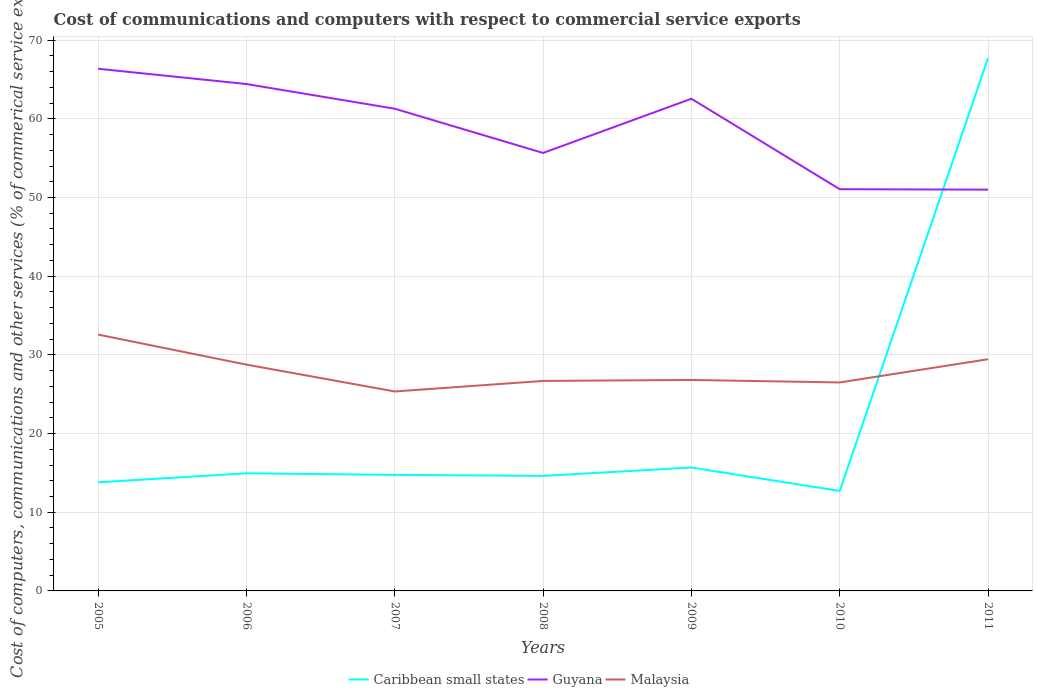Does the line corresponding to Malaysia intersect with the line corresponding to Caribbean small states?
Keep it short and to the point. Yes. Is the number of lines equal to the number of legend labels?
Keep it short and to the point. Yes. Across all years, what is the maximum cost of communications and computers in Caribbean small states?
Offer a terse response. 12.7. In which year was the cost of communications and computers in Guyana maximum?
Provide a short and direct response. 2011. What is the total cost of communications and computers in Guyana in the graph?
Keep it short and to the point. 5.08. What is the difference between the highest and the second highest cost of communications and computers in Guyana?
Make the answer very short. 15.36. What is the difference between the highest and the lowest cost of communications and computers in Guyana?
Ensure brevity in your answer.  4. What is the difference between two consecutive major ticks on the Y-axis?
Your response must be concise. 10. Are the values on the major ticks of Y-axis written in scientific E-notation?
Provide a succinct answer. No. Does the graph contain any zero values?
Your answer should be very brief. No. Does the graph contain grids?
Make the answer very short. Yes. What is the title of the graph?
Offer a terse response. Cost of communications and computers with respect to commercial service exports. What is the label or title of the X-axis?
Provide a short and direct response. Years. What is the label or title of the Y-axis?
Make the answer very short. Cost of computers, communications and other services (% of commerical service exports). What is the Cost of computers, communications and other services (% of commerical service exports) in Caribbean small states in 2005?
Provide a succinct answer. 13.81. What is the Cost of computers, communications and other services (% of commerical service exports) of Guyana in 2005?
Ensure brevity in your answer.  66.36. What is the Cost of computers, communications and other services (% of commerical service exports) of Malaysia in 2005?
Provide a short and direct response. 32.58. What is the Cost of computers, communications and other services (% of commerical service exports) in Caribbean small states in 2006?
Provide a succinct answer. 14.95. What is the Cost of computers, communications and other services (% of commerical service exports) of Guyana in 2006?
Keep it short and to the point. 64.42. What is the Cost of computers, communications and other services (% of commerical service exports) in Malaysia in 2006?
Your answer should be compact. 28.76. What is the Cost of computers, communications and other services (% of commerical service exports) of Caribbean small states in 2007?
Your answer should be compact. 14.75. What is the Cost of computers, communications and other services (% of commerical service exports) in Guyana in 2007?
Make the answer very short. 61.28. What is the Cost of computers, communications and other services (% of commerical service exports) of Malaysia in 2007?
Your answer should be compact. 25.35. What is the Cost of computers, communications and other services (% of commerical service exports) in Caribbean small states in 2008?
Provide a succinct answer. 14.62. What is the Cost of computers, communications and other services (% of commerical service exports) of Guyana in 2008?
Keep it short and to the point. 55.66. What is the Cost of computers, communications and other services (% of commerical service exports) of Malaysia in 2008?
Provide a short and direct response. 26.69. What is the Cost of computers, communications and other services (% of commerical service exports) in Caribbean small states in 2009?
Give a very brief answer. 15.68. What is the Cost of computers, communications and other services (% of commerical service exports) in Guyana in 2009?
Make the answer very short. 62.55. What is the Cost of computers, communications and other services (% of commerical service exports) in Malaysia in 2009?
Make the answer very short. 26.81. What is the Cost of computers, communications and other services (% of commerical service exports) of Caribbean small states in 2010?
Keep it short and to the point. 12.7. What is the Cost of computers, communications and other services (% of commerical service exports) of Guyana in 2010?
Make the answer very short. 51.06. What is the Cost of computers, communications and other services (% of commerical service exports) in Malaysia in 2010?
Provide a short and direct response. 26.5. What is the Cost of computers, communications and other services (% of commerical service exports) in Caribbean small states in 2011?
Ensure brevity in your answer.  67.71. What is the Cost of computers, communications and other services (% of commerical service exports) of Guyana in 2011?
Your answer should be compact. 51. What is the Cost of computers, communications and other services (% of commerical service exports) in Malaysia in 2011?
Make the answer very short. 29.45. Across all years, what is the maximum Cost of computers, communications and other services (% of commerical service exports) in Caribbean small states?
Keep it short and to the point. 67.71. Across all years, what is the maximum Cost of computers, communications and other services (% of commerical service exports) in Guyana?
Keep it short and to the point. 66.36. Across all years, what is the maximum Cost of computers, communications and other services (% of commerical service exports) of Malaysia?
Give a very brief answer. 32.58. Across all years, what is the minimum Cost of computers, communications and other services (% of commerical service exports) of Caribbean small states?
Give a very brief answer. 12.7. Across all years, what is the minimum Cost of computers, communications and other services (% of commerical service exports) of Guyana?
Provide a short and direct response. 51. Across all years, what is the minimum Cost of computers, communications and other services (% of commerical service exports) in Malaysia?
Give a very brief answer. 25.35. What is the total Cost of computers, communications and other services (% of commerical service exports) in Caribbean small states in the graph?
Your response must be concise. 154.22. What is the total Cost of computers, communications and other services (% of commerical service exports) of Guyana in the graph?
Offer a very short reply. 412.34. What is the total Cost of computers, communications and other services (% of commerical service exports) in Malaysia in the graph?
Keep it short and to the point. 196.14. What is the difference between the Cost of computers, communications and other services (% of commerical service exports) in Caribbean small states in 2005 and that in 2006?
Give a very brief answer. -1.14. What is the difference between the Cost of computers, communications and other services (% of commerical service exports) of Guyana in 2005 and that in 2006?
Your answer should be compact. 1.94. What is the difference between the Cost of computers, communications and other services (% of commerical service exports) of Malaysia in 2005 and that in 2006?
Provide a short and direct response. 3.82. What is the difference between the Cost of computers, communications and other services (% of commerical service exports) in Caribbean small states in 2005 and that in 2007?
Your response must be concise. -0.94. What is the difference between the Cost of computers, communications and other services (% of commerical service exports) of Guyana in 2005 and that in 2007?
Offer a terse response. 5.08. What is the difference between the Cost of computers, communications and other services (% of commerical service exports) of Malaysia in 2005 and that in 2007?
Offer a very short reply. 7.23. What is the difference between the Cost of computers, communications and other services (% of commerical service exports) in Caribbean small states in 2005 and that in 2008?
Offer a very short reply. -0.81. What is the difference between the Cost of computers, communications and other services (% of commerical service exports) of Guyana in 2005 and that in 2008?
Make the answer very short. 10.7. What is the difference between the Cost of computers, communications and other services (% of commerical service exports) of Malaysia in 2005 and that in 2008?
Keep it short and to the point. 5.89. What is the difference between the Cost of computers, communications and other services (% of commerical service exports) of Caribbean small states in 2005 and that in 2009?
Your response must be concise. -1.88. What is the difference between the Cost of computers, communications and other services (% of commerical service exports) of Guyana in 2005 and that in 2009?
Your answer should be very brief. 3.81. What is the difference between the Cost of computers, communications and other services (% of commerical service exports) in Malaysia in 2005 and that in 2009?
Offer a terse response. 5.76. What is the difference between the Cost of computers, communications and other services (% of commerical service exports) of Caribbean small states in 2005 and that in 2010?
Your response must be concise. 1.1. What is the difference between the Cost of computers, communications and other services (% of commerical service exports) of Guyana in 2005 and that in 2010?
Provide a short and direct response. 15.31. What is the difference between the Cost of computers, communications and other services (% of commerical service exports) of Malaysia in 2005 and that in 2010?
Your answer should be very brief. 6.08. What is the difference between the Cost of computers, communications and other services (% of commerical service exports) in Caribbean small states in 2005 and that in 2011?
Offer a terse response. -53.9. What is the difference between the Cost of computers, communications and other services (% of commerical service exports) of Guyana in 2005 and that in 2011?
Provide a short and direct response. 15.36. What is the difference between the Cost of computers, communications and other services (% of commerical service exports) of Malaysia in 2005 and that in 2011?
Your response must be concise. 3.13. What is the difference between the Cost of computers, communications and other services (% of commerical service exports) in Caribbean small states in 2006 and that in 2007?
Your answer should be compact. 0.2. What is the difference between the Cost of computers, communications and other services (% of commerical service exports) of Guyana in 2006 and that in 2007?
Keep it short and to the point. 3.14. What is the difference between the Cost of computers, communications and other services (% of commerical service exports) in Malaysia in 2006 and that in 2007?
Make the answer very short. 3.41. What is the difference between the Cost of computers, communications and other services (% of commerical service exports) in Caribbean small states in 2006 and that in 2008?
Offer a very short reply. 0.33. What is the difference between the Cost of computers, communications and other services (% of commerical service exports) in Guyana in 2006 and that in 2008?
Give a very brief answer. 8.76. What is the difference between the Cost of computers, communications and other services (% of commerical service exports) of Malaysia in 2006 and that in 2008?
Offer a terse response. 2.07. What is the difference between the Cost of computers, communications and other services (% of commerical service exports) in Caribbean small states in 2006 and that in 2009?
Your response must be concise. -0.73. What is the difference between the Cost of computers, communications and other services (% of commerical service exports) of Guyana in 2006 and that in 2009?
Keep it short and to the point. 1.87. What is the difference between the Cost of computers, communications and other services (% of commerical service exports) of Malaysia in 2006 and that in 2009?
Your answer should be compact. 1.94. What is the difference between the Cost of computers, communications and other services (% of commerical service exports) of Caribbean small states in 2006 and that in 2010?
Ensure brevity in your answer.  2.25. What is the difference between the Cost of computers, communications and other services (% of commerical service exports) in Guyana in 2006 and that in 2010?
Offer a very short reply. 13.36. What is the difference between the Cost of computers, communications and other services (% of commerical service exports) in Malaysia in 2006 and that in 2010?
Provide a short and direct response. 2.26. What is the difference between the Cost of computers, communications and other services (% of commerical service exports) of Caribbean small states in 2006 and that in 2011?
Provide a succinct answer. -52.75. What is the difference between the Cost of computers, communications and other services (% of commerical service exports) of Guyana in 2006 and that in 2011?
Your response must be concise. 13.42. What is the difference between the Cost of computers, communications and other services (% of commerical service exports) of Malaysia in 2006 and that in 2011?
Provide a short and direct response. -0.69. What is the difference between the Cost of computers, communications and other services (% of commerical service exports) in Caribbean small states in 2007 and that in 2008?
Your response must be concise. 0.13. What is the difference between the Cost of computers, communications and other services (% of commerical service exports) of Guyana in 2007 and that in 2008?
Provide a short and direct response. 5.62. What is the difference between the Cost of computers, communications and other services (% of commerical service exports) of Malaysia in 2007 and that in 2008?
Offer a very short reply. -1.34. What is the difference between the Cost of computers, communications and other services (% of commerical service exports) in Caribbean small states in 2007 and that in 2009?
Offer a terse response. -0.94. What is the difference between the Cost of computers, communications and other services (% of commerical service exports) in Guyana in 2007 and that in 2009?
Provide a short and direct response. -1.27. What is the difference between the Cost of computers, communications and other services (% of commerical service exports) of Malaysia in 2007 and that in 2009?
Your answer should be compact. -1.46. What is the difference between the Cost of computers, communications and other services (% of commerical service exports) of Caribbean small states in 2007 and that in 2010?
Keep it short and to the point. 2.04. What is the difference between the Cost of computers, communications and other services (% of commerical service exports) of Guyana in 2007 and that in 2010?
Offer a very short reply. 10.23. What is the difference between the Cost of computers, communications and other services (% of commerical service exports) in Malaysia in 2007 and that in 2010?
Provide a short and direct response. -1.15. What is the difference between the Cost of computers, communications and other services (% of commerical service exports) of Caribbean small states in 2007 and that in 2011?
Offer a terse response. -52.96. What is the difference between the Cost of computers, communications and other services (% of commerical service exports) of Guyana in 2007 and that in 2011?
Ensure brevity in your answer.  10.28. What is the difference between the Cost of computers, communications and other services (% of commerical service exports) of Malaysia in 2007 and that in 2011?
Ensure brevity in your answer.  -4.1. What is the difference between the Cost of computers, communications and other services (% of commerical service exports) of Caribbean small states in 2008 and that in 2009?
Your answer should be compact. -1.06. What is the difference between the Cost of computers, communications and other services (% of commerical service exports) of Guyana in 2008 and that in 2009?
Keep it short and to the point. -6.89. What is the difference between the Cost of computers, communications and other services (% of commerical service exports) in Malaysia in 2008 and that in 2009?
Your answer should be very brief. -0.12. What is the difference between the Cost of computers, communications and other services (% of commerical service exports) of Caribbean small states in 2008 and that in 2010?
Offer a terse response. 1.91. What is the difference between the Cost of computers, communications and other services (% of commerical service exports) of Guyana in 2008 and that in 2010?
Offer a terse response. 4.6. What is the difference between the Cost of computers, communications and other services (% of commerical service exports) of Malaysia in 2008 and that in 2010?
Your response must be concise. 0.19. What is the difference between the Cost of computers, communications and other services (% of commerical service exports) of Caribbean small states in 2008 and that in 2011?
Make the answer very short. -53.09. What is the difference between the Cost of computers, communications and other services (% of commerical service exports) in Guyana in 2008 and that in 2011?
Keep it short and to the point. 4.66. What is the difference between the Cost of computers, communications and other services (% of commerical service exports) of Malaysia in 2008 and that in 2011?
Offer a very short reply. -2.76. What is the difference between the Cost of computers, communications and other services (% of commerical service exports) in Caribbean small states in 2009 and that in 2010?
Your response must be concise. 2.98. What is the difference between the Cost of computers, communications and other services (% of commerical service exports) of Guyana in 2009 and that in 2010?
Provide a succinct answer. 11.5. What is the difference between the Cost of computers, communications and other services (% of commerical service exports) of Malaysia in 2009 and that in 2010?
Keep it short and to the point. 0.32. What is the difference between the Cost of computers, communications and other services (% of commerical service exports) in Caribbean small states in 2009 and that in 2011?
Your response must be concise. -52.02. What is the difference between the Cost of computers, communications and other services (% of commerical service exports) of Guyana in 2009 and that in 2011?
Ensure brevity in your answer.  11.55. What is the difference between the Cost of computers, communications and other services (% of commerical service exports) in Malaysia in 2009 and that in 2011?
Provide a succinct answer. -2.63. What is the difference between the Cost of computers, communications and other services (% of commerical service exports) of Caribbean small states in 2010 and that in 2011?
Keep it short and to the point. -55. What is the difference between the Cost of computers, communications and other services (% of commerical service exports) of Guyana in 2010 and that in 2011?
Provide a succinct answer. 0.06. What is the difference between the Cost of computers, communications and other services (% of commerical service exports) in Malaysia in 2010 and that in 2011?
Provide a short and direct response. -2.95. What is the difference between the Cost of computers, communications and other services (% of commerical service exports) of Caribbean small states in 2005 and the Cost of computers, communications and other services (% of commerical service exports) of Guyana in 2006?
Give a very brief answer. -50.62. What is the difference between the Cost of computers, communications and other services (% of commerical service exports) in Caribbean small states in 2005 and the Cost of computers, communications and other services (% of commerical service exports) in Malaysia in 2006?
Give a very brief answer. -14.95. What is the difference between the Cost of computers, communications and other services (% of commerical service exports) of Guyana in 2005 and the Cost of computers, communications and other services (% of commerical service exports) of Malaysia in 2006?
Make the answer very short. 37.61. What is the difference between the Cost of computers, communications and other services (% of commerical service exports) of Caribbean small states in 2005 and the Cost of computers, communications and other services (% of commerical service exports) of Guyana in 2007?
Offer a very short reply. -47.48. What is the difference between the Cost of computers, communications and other services (% of commerical service exports) of Caribbean small states in 2005 and the Cost of computers, communications and other services (% of commerical service exports) of Malaysia in 2007?
Offer a very short reply. -11.54. What is the difference between the Cost of computers, communications and other services (% of commerical service exports) in Guyana in 2005 and the Cost of computers, communications and other services (% of commerical service exports) in Malaysia in 2007?
Make the answer very short. 41.01. What is the difference between the Cost of computers, communications and other services (% of commerical service exports) of Caribbean small states in 2005 and the Cost of computers, communications and other services (% of commerical service exports) of Guyana in 2008?
Give a very brief answer. -41.86. What is the difference between the Cost of computers, communications and other services (% of commerical service exports) of Caribbean small states in 2005 and the Cost of computers, communications and other services (% of commerical service exports) of Malaysia in 2008?
Provide a succinct answer. -12.88. What is the difference between the Cost of computers, communications and other services (% of commerical service exports) of Guyana in 2005 and the Cost of computers, communications and other services (% of commerical service exports) of Malaysia in 2008?
Offer a very short reply. 39.68. What is the difference between the Cost of computers, communications and other services (% of commerical service exports) of Caribbean small states in 2005 and the Cost of computers, communications and other services (% of commerical service exports) of Guyana in 2009?
Your response must be concise. -48.75. What is the difference between the Cost of computers, communications and other services (% of commerical service exports) in Caribbean small states in 2005 and the Cost of computers, communications and other services (% of commerical service exports) in Malaysia in 2009?
Provide a short and direct response. -13.01. What is the difference between the Cost of computers, communications and other services (% of commerical service exports) of Guyana in 2005 and the Cost of computers, communications and other services (% of commerical service exports) of Malaysia in 2009?
Your answer should be compact. 39.55. What is the difference between the Cost of computers, communications and other services (% of commerical service exports) in Caribbean small states in 2005 and the Cost of computers, communications and other services (% of commerical service exports) in Guyana in 2010?
Give a very brief answer. -37.25. What is the difference between the Cost of computers, communications and other services (% of commerical service exports) of Caribbean small states in 2005 and the Cost of computers, communications and other services (% of commerical service exports) of Malaysia in 2010?
Offer a very short reply. -12.69. What is the difference between the Cost of computers, communications and other services (% of commerical service exports) of Guyana in 2005 and the Cost of computers, communications and other services (% of commerical service exports) of Malaysia in 2010?
Ensure brevity in your answer.  39.87. What is the difference between the Cost of computers, communications and other services (% of commerical service exports) of Caribbean small states in 2005 and the Cost of computers, communications and other services (% of commerical service exports) of Guyana in 2011?
Provide a succinct answer. -37.19. What is the difference between the Cost of computers, communications and other services (% of commerical service exports) in Caribbean small states in 2005 and the Cost of computers, communications and other services (% of commerical service exports) in Malaysia in 2011?
Keep it short and to the point. -15.64. What is the difference between the Cost of computers, communications and other services (% of commerical service exports) in Guyana in 2005 and the Cost of computers, communications and other services (% of commerical service exports) in Malaysia in 2011?
Keep it short and to the point. 36.92. What is the difference between the Cost of computers, communications and other services (% of commerical service exports) in Caribbean small states in 2006 and the Cost of computers, communications and other services (% of commerical service exports) in Guyana in 2007?
Your answer should be compact. -46.33. What is the difference between the Cost of computers, communications and other services (% of commerical service exports) of Caribbean small states in 2006 and the Cost of computers, communications and other services (% of commerical service exports) of Malaysia in 2007?
Provide a succinct answer. -10.4. What is the difference between the Cost of computers, communications and other services (% of commerical service exports) in Guyana in 2006 and the Cost of computers, communications and other services (% of commerical service exports) in Malaysia in 2007?
Your answer should be very brief. 39.07. What is the difference between the Cost of computers, communications and other services (% of commerical service exports) of Caribbean small states in 2006 and the Cost of computers, communications and other services (% of commerical service exports) of Guyana in 2008?
Keep it short and to the point. -40.71. What is the difference between the Cost of computers, communications and other services (% of commerical service exports) of Caribbean small states in 2006 and the Cost of computers, communications and other services (% of commerical service exports) of Malaysia in 2008?
Ensure brevity in your answer.  -11.74. What is the difference between the Cost of computers, communications and other services (% of commerical service exports) of Guyana in 2006 and the Cost of computers, communications and other services (% of commerical service exports) of Malaysia in 2008?
Ensure brevity in your answer.  37.73. What is the difference between the Cost of computers, communications and other services (% of commerical service exports) in Caribbean small states in 2006 and the Cost of computers, communications and other services (% of commerical service exports) in Guyana in 2009?
Provide a short and direct response. -47.6. What is the difference between the Cost of computers, communications and other services (% of commerical service exports) of Caribbean small states in 2006 and the Cost of computers, communications and other services (% of commerical service exports) of Malaysia in 2009?
Give a very brief answer. -11.86. What is the difference between the Cost of computers, communications and other services (% of commerical service exports) of Guyana in 2006 and the Cost of computers, communications and other services (% of commerical service exports) of Malaysia in 2009?
Your response must be concise. 37.61. What is the difference between the Cost of computers, communications and other services (% of commerical service exports) of Caribbean small states in 2006 and the Cost of computers, communications and other services (% of commerical service exports) of Guyana in 2010?
Keep it short and to the point. -36.11. What is the difference between the Cost of computers, communications and other services (% of commerical service exports) in Caribbean small states in 2006 and the Cost of computers, communications and other services (% of commerical service exports) in Malaysia in 2010?
Offer a very short reply. -11.55. What is the difference between the Cost of computers, communications and other services (% of commerical service exports) in Guyana in 2006 and the Cost of computers, communications and other services (% of commerical service exports) in Malaysia in 2010?
Your answer should be compact. 37.92. What is the difference between the Cost of computers, communications and other services (% of commerical service exports) of Caribbean small states in 2006 and the Cost of computers, communications and other services (% of commerical service exports) of Guyana in 2011?
Your answer should be compact. -36.05. What is the difference between the Cost of computers, communications and other services (% of commerical service exports) of Caribbean small states in 2006 and the Cost of computers, communications and other services (% of commerical service exports) of Malaysia in 2011?
Your answer should be compact. -14.5. What is the difference between the Cost of computers, communications and other services (% of commerical service exports) in Guyana in 2006 and the Cost of computers, communications and other services (% of commerical service exports) in Malaysia in 2011?
Keep it short and to the point. 34.97. What is the difference between the Cost of computers, communications and other services (% of commerical service exports) of Caribbean small states in 2007 and the Cost of computers, communications and other services (% of commerical service exports) of Guyana in 2008?
Offer a terse response. -40.91. What is the difference between the Cost of computers, communications and other services (% of commerical service exports) of Caribbean small states in 2007 and the Cost of computers, communications and other services (% of commerical service exports) of Malaysia in 2008?
Ensure brevity in your answer.  -11.94. What is the difference between the Cost of computers, communications and other services (% of commerical service exports) of Guyana in 2007 and the Cost of computers, communications and other services (% of commerical service exports) of Malaysia in 2008?
Your answer should be very brief. 34.59. What is the difference between the Cost of computers, communications and other services (% of commerical service exports) in Caribbean small states in 2007 and the Cost of computers, communications and other services (% of commerical service exports) in Guyana in 2009?
Provide a succinct answer. -47.81. What is the difference between the Cost of computers, communications and other services (% of commerical service exports) of Caribbean small states in 2007 and the Cost of computers, communications and other services (% of commerical service exports) of Malaysia in 2009?
Provide a short and direct response. -12.07. What is the difference between the Cost of computers, communications and other services (% of commerical service exports) in Guyana in 2007 and the Cost of computers, communications and other services (% of commerical service exports) in Malaysia in 2009?
Offer a terse response. 34.47. What is the difference between the Cost of computers, communications and other services (% of commerical service exports) in Caribbean small states in 2007 and the Cost of computers, communications and other services (% of commerical service exports) in Guyana in 2010?
Offer a very short reply. -36.31. What is the difference between the Cost of computers, communications and other services (% of commerical service exports) in Caribbean small states in 2007 and the Cost of computers, communications and other services (% of commerical service exports) in Malaysia in 2010?
Give a very brief answer. -11.75. What is the difference between the Cost of computers, communications and other services (% of commerical service exports) of Guyana in 2007 and the Cost of computers, communications and other services (% of commerical service exports) of Malaysia in 2010?
Give a very brief answer. 34.79. What is the difference between the Cost of computers, communications and other services (% of commerical service exports) of Caribbean small states in 2007 and the Cost of computers, communications and other services (% of commerical service exports) of Guyana in 2011?
Offer a very short reply. -36.25. What is the difference between the Cost of computers, communications and other services (% of commerical service exports) in Caribbean small states in 2007 and the Cost of computers, communications and other services (% of commerical service exports) in Malaysia in 2011?
Your answer should be very brief. -14.7. What is the difference between the Cost of computers, communications and other services (% of commerical service exports) of Guyana in 2007 and the Cost of computers, communications and other services (% of commerical service exports) of Malaysia in 2011?
Give a very brief answer. 31.84. What is the difference between the Cost of computers, communications and other services (% of commerical service exports) in Caribbean small states in 2008 and the Cost of computers, communications and other services (% of commerical service exports) in Guyana in 2009?
Give a very brief answer. -47.94. What is the difference between the Cost of computers, communications and other services (% of commerical service exports) in Caribbean small states in 2008 and the Cost of computers, communications and other services (% of commerical service exports) in Malaysia in 2009?
Your response must be concise. -12.19. What is the difference between the Cost of computers, communications and other services (% of commerical service exports) of Guyana in 2008 and the Cost of computers, communications and other services (% of commerical service exports) of Malaysia in 2009?
Offer a very short reply. 28.85. What is the difference between the Cost of computers, communications and other services (% of commerical service exports) in Caribbean small states in 2008 and the Cost of computers, communications and other services (% of commerical service exports) in Guyana in 2010?
Provide a succinct answer. -36.44. What is the difference between the Cost of computers, communications and other services (% of commerical service exports) in Caribbean small states in 2008 and the Cost of computers, communications and other services (% of commerical service exports) in Malaysia in 2010?
Make the answer very short. -11.88. What is the difference between the Cost of computers, communications and other services (% of commerical service exports) of Guyana in 2008 and the Cost of computers, communications and other services (% of commerical service exports) of Malaysia in 2010?
Your answer should be compact. 29.16. What is the difference between the Cost of computers, communications and other services (% of commerical service exports) of Caribbean small states in 2008 and the Cost of computers, communications and other services (% of commerical service exports) of Guyana in 2011?
Offer a terse response. -36.38. What is the difference between the Cost of computers, communications and other services (% of commerical service exports) of Caribbean small states in 2008 and the Cost of computers, communications and other services (% of commerical service exports) of Malaysia in 2011?
Make the answer very short. -14.83. What is the difference between the Cost of computers, communications and other services (% of commerical service exports) in Guyana in 2008 and the Cost of computers, communications and other services (% of commerical service exports) in Malaysia in 2011?
Your answer should be compact. 26.21. What is the difference between the Cost of computers, communications and other services (% of commerical service exports) of Caribbean small states in 2009 and the Cost of computers, communications and other services (% of commerical service exports) of Guyana in 2010?
Make the answer very short. -35.37. What is the difference between the Cost of computers, communications and other services (% of commerical service exports) in Caribbean small states in 2009 and the Cost of computers, communications and other services (% of commerical service exports) in Malaysia in 2010?
Offer a very short reply. -10.81. What is the difference between the Cost of computers, communications and other services (% of commerical service exports) in Guyana in 2009 and the Cost of computers, communications and other services (% of commerical service exports) in Malaysia in 2010?
Offer a terse response. 36.06. What is the difference between the Cost of computers, communications and other services (% of commerical service exports) of Caribbean small states in 2009 and the Cost of computers, communications and other services (% of commerical service exports) of Guyana in 2011?
Your answer should be very brief. -35.32. What is the difference between the Cost of computers, communications and other services (% of commerical service exports) of Caribbean small states in 2009 and the Cost of computers, communications and other services (% of commerical service exports) of Malaysia in 2011?
Make the answer very short. -13.76. What is the difference between the Cost of computers, communications and other services (% of commerical service exports) of Guyana in 2009 and the Cost of computers, communications and other services (% of commerical service exports) of Malaysia in 2011?
Keep it short and to the point. 33.11. What is the difference between the Cost of computers, communications and other services (% of commerical service exports) of Caribbean small states in 2010 and the Cost of computers, communications and other services (% of commerical service exports) of Guyana in 2011?
Offer a very short reply. -38.3. What is the difference between the Cost of computers, communications and other services (% of commerical service exports) in Caribbean small states in 2010 and the Cost of computers, communications and other services (% of commerical service exports) in Malaysia in 2011?
Your answer should be compact. -16.74. What is the difference between the Cost of computers, communications and other services (% of commerical service exports) in Guyana in 2010 and the Cost of computers, communications and other services (% of commerical service exports) in Malaysia in 2011?
Provide a short and direct response. 21.61. What is the average Cost of computers, communications and other services (% of commerical service exports) in Caribbean small states per year?
Keep it short and to the point. 22.03. What is the average Cost of computers, communications and other services (% of commerical service exports) in Guyana per year?
Your answer should be very brief. 58.91. What is the average Cost of computers, communications and other services (% of commerical service exports) in Malaysia per year?
Ensure brevity in your answer.  28.02. In the year 2005, what is the difference between the Cost of computers, communications and other services (% of commerical service exports) of Caribbean small states and Cost of computers, communications and other services (% of commerical service exports) of Guyana?
Your answer should be compact. -52.56. In the year 2005, what is the difference between the Cost of computers, communications and other services (% of commerical service exports) of Caribbean small states and Cost of computers, communications and other services (% of commerical service exports) of Malaysia?
Keep it short and to the point. -18.77. In the year 2005, what is the difference between the Cost of computers, communications and other services (% of commerical service exports) of Guyana and Cost of computers, communications and other services (% of commerical service exports) of Malaysia?
Ensure brevity in your answer.  33.79. In the year 2006, what is the difference between the Cost of computers, communications and other services (% of commerical service exports) of Caribbean small states and Cost of computers, communications and other services (% of commerical service exports) of Guyana?
Make the answer very short. -49.47. In the year 2006, what is the difference between the Cost of computers, communications and other services (% of commerical service exports) in Caribbean small states and Cost of computers, communications and other services (% of commerical service exports) in Malaysia?
Ensure brevity in your answer.  -13.81. In the year 2006, what is the difference between the Cost of computers, communications and other services (% of commerical service exports) in Guyana and Cost of computers, communications and other services (% of commerical service exports) in Malaysia?
Offer a very short reply. 35.66. In the year 2007, what is the difference between the Cost of computers, communications and other services (% of commerical service exports) of Caribbean small states and Cost of computers, communications and other services (% of commerical service exports) of Guyana?
Your response must be concise. -46.54. In the year 2007, what is the difference between the Cost of computers, communications and other services (% of commerical service exports) of Caribbean small states and Cost of computers, communications and other services (% of commerical service exports) of Malaysia?
Make the answer very short. -10.6. In the year 2007, what is the difference between the Cost of computers, communications and other services (% of commerical service exports) in Guyana and Cost of computers, communications and other services (% of commerical service exports) in Malaysia?
Offer a terse response. 35.93. In the year 2008, what is the difference between the Cost of computers, communications and other services (% of commerical service exports) of Caribbean small states and Cost of computers, communications and other services (% of commerical service exports) of Guyana?
Keep it short and to the point. -41.04. In the year 2008, what is the difference between the Cost of computers, communications and other services (% of commerical service exports) in Caribbean small states and Cost of computers, communications and other services (% of commerical service exports) in Malaysia?
Your answer should be very brief. -12.07. In the year 2008, what is the difference between the Cost of computers, communications and other services (% of commerical service exports) in Guyana and Cost of computers, communications and other services (% of commerical service exports) in Malaysia?
Give a very brief answer. 28.97. In the year 2009, what is the difference between the Cost of computers, communications and other services (% of commerical service exports) in Caribbean small states and Cost of computers, communications and other services (% of commerical service exports) in Guyana?
Make the answer very short. -46.87. In the year 2009, what is the difference between the Cost of computers, communications and other services (% of commerical service exports) of Caribbean small states and Cost of computers, communications and other services (% of commerical service exports) of Malaysia?
Ensure brevity in your answer.  -11.13. In the year 2009, what is the difference between the Cost of computers, communications and other services (% of commerical service exports) in Guyana and Cost of computers, communications and other services (% of commerical service exports) in Malaysia?
Offer a terse response. 35.74. In the year 2010, what is the difference between the Cost of computers, communications and other services (% of commerical service exports) in Caribbean small states and Cost of computers, communications and other services (% of commerical service exports) in Guyana?
Your response must be concise. -38.35. In the year 2010, what is the difference between the Cost of computers, communications and other services (% of commerical service exports) in Caribbean small states and Cost of computers, communications and other services (% of commerical service exports) in Malaysia?
Provide a short and direct response. -13.79. In the year 2010, what is the difference between the Cost of computers, communications and other services (% of commerical service exports) in Guyana and Cost of computers, communications and other services (% of commerical service exports) in Malaysia?
Offer a very short reply. 24.56. In the year 2011, what is the difference between the Cost of computers, communications and other services (% of commerical service exports) of Caribbean small states and Cost of computers, communications and other services (% of commerical service exports) of Guyana?
Offer a terse response. 16.7. In the year 2011, what is the difference between the Cost of computers, communications and other services (% of commerical service exports) of Caribbean small states and Cost of computers, communications and other services (% of commerical service exports) of Malaysia?
Offer a terse response. 38.26. In the year 2011, what is the difference between the Cost of computers, communications and other services (% of commerical service exports) in Guyana and Cost of computers, communications and other services (% of commerical service exports) in Malaysia?
Make the answer very short. 21.55. What is the ratio of the Cost of computers, communications and other services (% of commerical service exports) of Caribbean small states in 2005 to that in 2006?
Provide a succinct answer. 0.92. What is the ratio of the Cost of computers, communications and other services (% of commerical service exports) of Guyana in 2005 to that in 2006?
Provide a succinct answer. 1.03. What is the ratio of the Cost of computers, communications and other services (% of commerical service exports) of Malaysia in 2005 to that in 2006?
Keep it short and to the point. 1.13. What is the ratio of the Cost of computers, communications and other services (% of commerical service exports) in Caribbean small states in 2005 to that in 2007?
Your answer should be very brief. 0.94. What is the ratio of the Cost of computers, communications and other services (% of commerical service exports) in Guyana in 2005 to that in 2007?
Make the answer very short. 1.08. What is the ratio of the Cost of computers, communications and other services (% of commerical service exports) of Malaysia in 2005 to that in 2007?
Your response must be concise. 1.29. What is the ratio of the Cost of computers, communications and other services (% of commerical service exports) of Caribbean small states in 2005 to that in 2008?
Your answer should be very brief. 0.94. What is the ratio of the Cost of computers, communications and other services (% of commerical service exports) of Guyana in 2005 to that in 2008?
Give a very brief answer. 1.19. What is the ratio of the Cost of computers, communications and other services (% of commerical service exports) of Malaysia in 2005 to that in 2008?
Your response must be concise. 1.22. What is the ratio of the Cost of computers, communications and other services (% of commerical service exports) in Caribbean small states in 2005 to that in 2009?
Your answer should be compact. 0.88. What is the ratio of the Cost of computers, communications and other services (% of commerical service exports) in Guyana in 2005 to that in 2009?
Provide a succinct answer. 1.06. What is the ratio of the Cost of computers, communications and other services (% of commerical service exports) of Malaysia in 2005 to that in 2009?
Keep it short and to the point. 1.21. What is the ratio of the Cost of computers, communications and other services (% of commerical service exports) in Caribbean small states in 2005 to that in 2010?
Provide a succinct answer. 1.09. What is the ratio of the Cost of computers, communications and other services (% of commerical service exports) of Guyana in 2005 to that in 2010?
Provide a short and direct response. 1.3. What is the ratio of the Cost of computers, communications and other services (% of commerical service exports) of Malaysia in 2005 to that in 2010?
Your response must be concise. 1.23. What is the ratio of the Cost of computers, communications and other services (% of commerical service exports) of Caribbean small states in 2005 to that in 2011?
Your answer should be very brief. 0.2. What is the ratio of the Cost of computers, communications and other services (% of commerical service exports) of Guyana in 2005 to that in 2011?
Provide a short and direct response. 1.3. What is the ratio of the Cost of computers, communications and other services (% of commerical service exports) in Malaysia in 2005 to that in 2011?
Offer a very short reply. 1.11. What is the ratio of the Cost of computers, communications and other services (% of commerical service exports) of Caribbean small states in 2006 to that in 2007?
Provide a short and direct response. 1.01. What is the ratio of the Cost of computers, communications and other services (% of commerical service exports) of Guyana in 2006 to that in 2007?
Make the answer very short. 1.05. What is the ratio of the Cost of computers, communications and other services (% of commerical service exports) in Malaysia in 2006 to that in 2007?
Your response must be concise. 1.13. What is the ratio of the Cost of computers, communications and other services (% of commerical service exports) in Caribbean small states in 2006 to that in 2008?
Provide a short and direct response. 1.02. What is the ratio of the Cost of computers, communications and other services (% of commerical service exports) of Guyana in 2006 to that in 2008?
Offer a very short reply. 1.16. What is the ratio of the Cost of computers, communications and other services (% of commerical service exports) of Malaysia in 2006 to that in 2008?
Your answer should be compact. 1.08. What is the ratio of the Cost of computers, communications and other services (% of commerical service exports) in Caribbean small states in 2006 to that in 2009?
Keep it short and to the point. 0.95. What is the ratio of the Cost of computers, communications and other services (% of commerical service exports) of Guyana in 2006 to that in 2009?
Your response must be concise. 1.03. What is the ratio of the Cost of computers, communications and other services (% of commerical service exports) of Malaysia in 2006 to that in 2009?
Provide a succinct answer. 1.07. What is the ratio of the Cost of computers, communications and other services (% of commerical service exports) of Caribbean small states in 2006 to that in 2010?
Keep it short and to the point. 1.18. What is the ratio of the Cost of computers, communications and other services (% of commerical service exports) in Guyana in 2006 to that in 2010?
Give a very brief answer. 1.26. What is the ratio of the Cost of computers, communications and other services (% of commerical service exports) of Malaysia in 2006 to that in 2010?
Ensure brevity in your answer.  1.09. What is the ratio of the Cost of computers, communications and other services (% of commerical service exports) in Caribbean small states in 2006 to that in 2011?
Offer a very short reply. 0.22. What is the ratio of the Cost of computers, communications and other services (% of commerical service exports) of Guyana in 2006 to that in 2011?
Make the answer very short. 1.26. What is the ratio of the Cost of computers, communications and other services (% of commerical service exports) of Malaysia in 2006 to that in 2011?
Provide a succinct answer. 0.98. What is the ratio of the Cost of computers, communications and other services (% of commerical service exports) of Caribbean small states in 2007 to that in 2008?
Offer a very short reply. 1.01. What is the ratio of the Cost of computers, communications and other services (% of commerical service exports) of Guyana in 2007 to that in 2008?
Your response must be concise. 1.1. What is the ratio of the Cost of computers, communications and other services (% of commerical service exports) of Malaysia in 2007 to that in 2008?
Give a very brief answer. 0.95. What is the ratio of the Cost of computers, communications and other services (% of commerical service exports) in Caribbean small states in 2007 to that in 2009?
Ensure brevity in your answer.  0.94. What is the ratio of the Cost of computers, communications and other services (% of commerical service exports) of Guyana in 2007 to that in 2009?
Offer a terse response. 0.98. What is the ratio of the Cost of computers, communications and other services (% of commerical service exports) of Malaysia in 2007 to that in 2009?
Your answer should be compact. 0.95. What is the ratio of the Cost of computers, communications and other services (% of commerical service exports) in Caribbean small states in 2007 to that in 2010?
Offer a very short reply. 1.16. What is the ratio of the Cost of computers, communications and other services (% of commerical service exports) in Guyana in 2007 to that in 2010?
Provide a succinct answer. 1.2. What is the ratio of the Cost of computers, communications and other services (% of commerical service exports) of Malaysia in 2007 to that in 2010?
Make the answer very short. 0.96. What is the ratio of the Cost of computers, communications and other services (% of commerical service exports) in Caribbean small states in 2007 to that in 2011?
Provide a succinct answer. 0.22. What is the ratio of the Cost of computers, communications and other services (% of commerical service exports) in Guyana in 2007 to that in 2011?
Provide a short and direct response. 1.2. What is the ratio of the Cost of computers, communications and other services (% of commerical service exports) in Malaysia in 2007 to that in 2011?
Provide a short and direct response. 0.86. What is the ratio of the Cost of computers, communications and other services (% of commerical service exports) in Caribbean small states in 2008 to that in 2009?
Give a very brief answer. 0.93. What is the ratio of the Cost of computers, communications and other services (% of commerical service exports) in Guyana in 2008 to that in 2009?
Your response must be concise. 0.89. What is the ratio of the Cost of computers, communications and other services (% of commerical service exports) of Caribbean small states in 2008 to that in 2010?
Your answer should be compact. 1.15. What is the ratio of the Cost of computers, communications and other services (% of commerical service exports) in Guyana in 2008 to that in 2010?
Ensure brevity in your answer.  1.09. What is the ratio of the Cost of computers, communications and other services (% of commerical service exports) of Malaysia in 2008 to that in 2010?
Keep it short and to the point. 1.01. What is the ratio of the Cost of computers, communications and other services (% of commerical service exports) in Caribbean small states in 2008 to that in 2011?
Give a very brief answer. 0.22. What is the ratio of the Cost of computers, communications and other services (% of commerical service exports) of Guyana in 2008 to that in 2011?
Your answer should be very brief. 1.09. What is the ratio of the Cost of computers, communications and other services (% of commerical service exports) in Malaysia in 2008 to that in 2011?
Give a very brief answer. 0.91. What is the ratio of the Cost of computers, communications and other services (% of commerical service exports) of Caribbean small states in 2009 to that in 2010?
Make the answer very short. 1.23. What is the ratio of the Cost of computers, communications and other services (% of commerical service exports) of Guyana in 2009 to that in 2010?
Offer a very short reply. 1.23. What is the ratio of the Cost of computers, communications and other services (% of commerical service exports) of Malaysia in 2009 to that in 2010?
Your answer should be compact. 1.01. What is the ratio of the Cost of computers, communications and other services (% of commerical service exports) in Caribbean small states in 2009 to that in 2011?
Offer a terse response. 0.23. What is the ratio of the Cost of computers, communications and other services (% of commerical service exports) in Guyana in 2009 to that in 2011?
Ensure brevity in your answer.  1.23. What is the ratio of the Cost of computers, communications and other services (% of commerical service exports) in Malaysia in 2009 to that in 2011?
Ensure brevity in your answer.  0.91. What is the ratio of the Cost of computers, communications and other services (% of commerical service exports) in Caribbean small states in 2010 to that in 2011?
Provide a succinct answer. 0.19. What is the ratio of the Cost of computers, communications and other services (% of commerical service exports) in Malaysia in 2010 to that in 2011?
Ensure brevity in your answer.  0.9. What is the difference between the highest and the second highest Cost of computers, communications and other services (% of commerical service exports) in Caribbean small states?
Your answer should be compact. 52.02. What is the difference between the highest and the second highest Cost of computers, communications and other services (% of commerical service exports) in Guyana?
Your response must be concise. 1.94. What is the difference between the highest and the second highest Cost of computers, communications and other services (% of commerical service exports) of Malaysia?
Ensure brevity in your answer.  3.13. What is the difference between the highest and the lowest Cost of computers, communications and other services (% of commerical service exports) of Caribbean small states?
Keep it short and to the point. 55. What is the difference between the highest and the lowest Cost of computers, communications and other services (% of commerical service exports) in Guyana?
Offer a very short reply. 15.36. What is the difference between the highest and the lowest Cost of computers, communications and other services (% of commerical service exports) in Malaysia?
Your answer should be very brief. 7.23. 